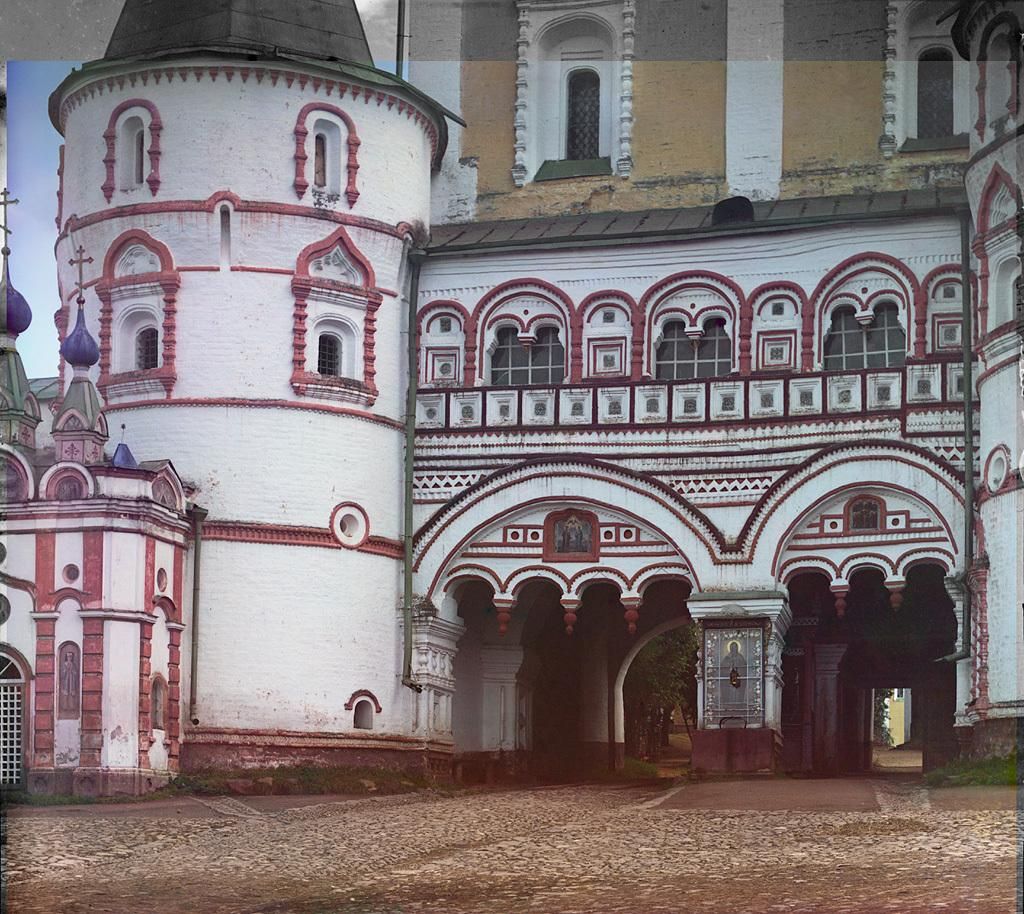What is the main subject in the middle of the image? There is a building in the middle of the image. What can be seen in the sky behind the building? There are clouds in the sky behind the building. What type of vegetation is visible in the image? There are trees visible in the image. What type of wheel can be seen in the image? There is no wheel present in the image. Is there a bathtub visible in the image? There is no bathtub present in the image. 